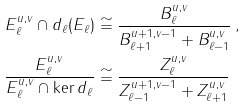<formula> <loc_0><loc_0><loc_500><loc_500>E _ { \ell } ^ { u , v } \cap d _ { \ell } ( E _ { \ell } ) & \cong \frac { B _ { \ell } ^ { u , v } } { B _ { \ell + 1 } ^ { u + 1 , v - 1 } + B _ { \ell - 1 } ^ { u , v } } \, , \\ \frac { E _ { \ell } ^ { u , v } } { E _ { \ell } ^ { u , v } \cap \ker d _ { \ell } } & \cong \frac { Z _ { \ell } ^ { u , v } } { Z _ { \ell - 1 } ^ { u + 1 , v - 1 } + Z _ { \ell + 1 } ^ { u , v } }</formula> 